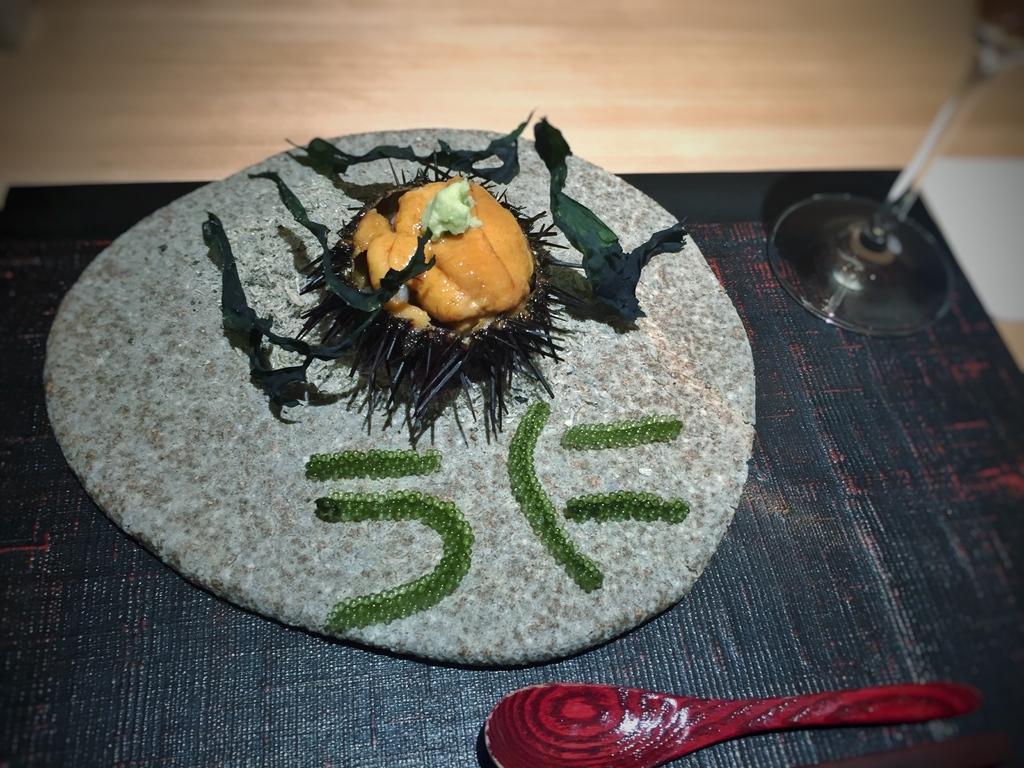In one or two sentences, can you explain what this image depicts? In this image there is a table we can see a glass, spoon, tray, food and a mat placed on the table. 